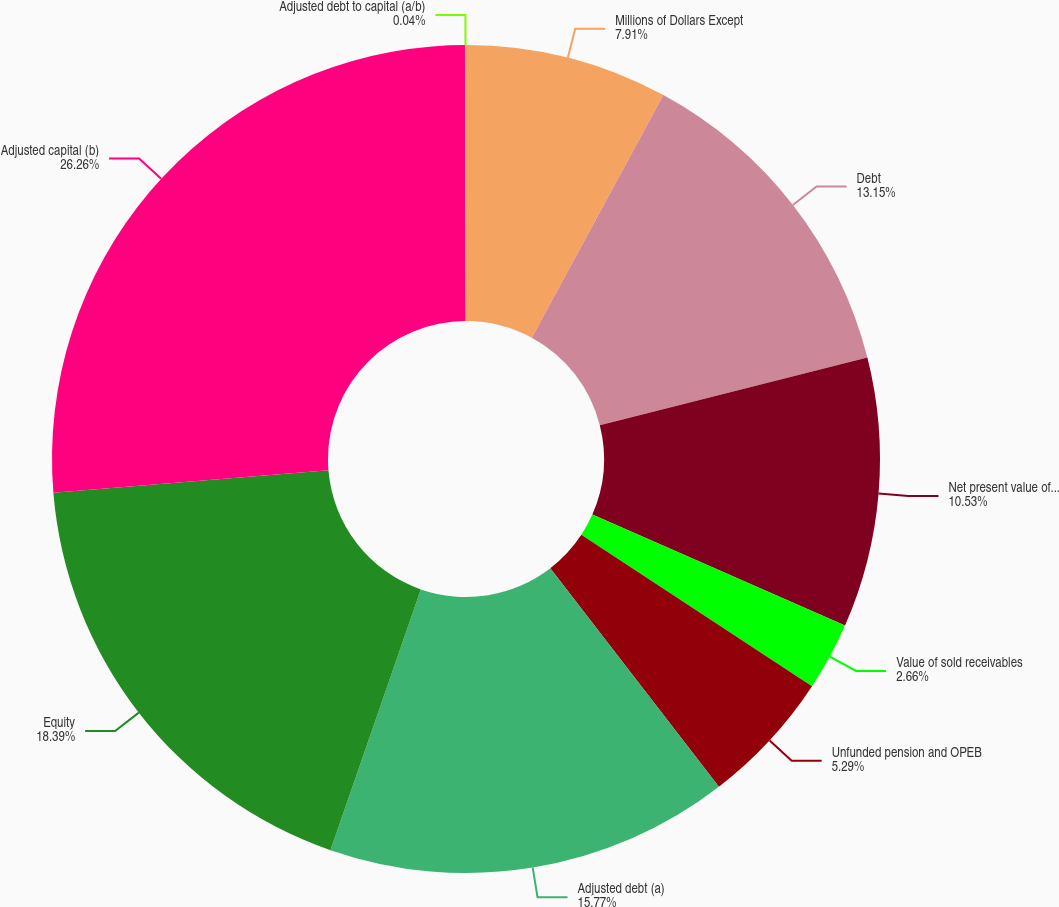Convert chart. <chart><loc_0><loc_0><loc_500><loc_500><pie_chart><fcel>Millions of Dollars Except<fcel>Debt<fcel>Net present value of operating<fcel>Value of sold receivables<fcel>Unfunded pension and OPEB<fcel>Adjusted debt (a)<fcel>Equity<fcel>Adjusted capital (b)<fcel>Adjusted debt to capital (a/b)<nl><fcel>7.91%<fcel>13.15%<fcel>10.53%<fcel>2.66%<fcel>5.29%<fcel>15.77%<fcel>18.39%<fcel>26.26%<fcel>0.04%<nl></chart> 